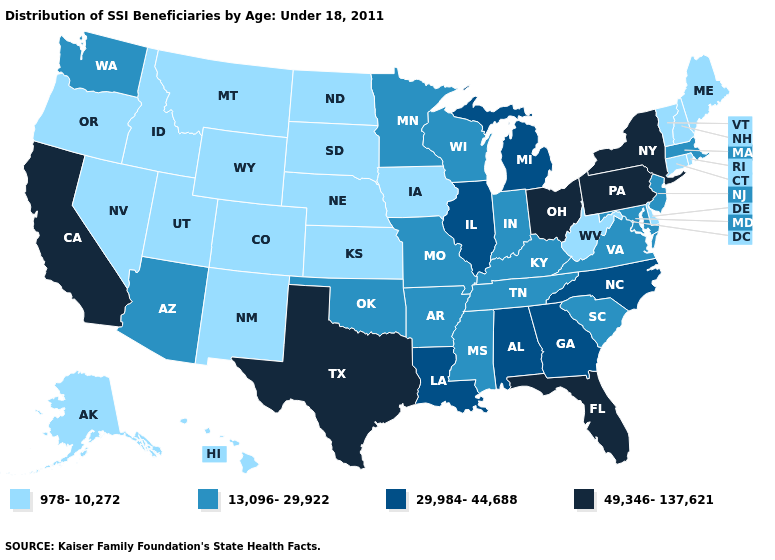Name the states that have a value in the range 13,096-29,922?
Short answer required. Arizona, Arkansas, Indiana, Kentucky, Maryland, Massachusetts, Minnesota, Mississippi, Missouri, New Jersey, Oklahoma, South Carolina, Tennessee, Virginia, Washington, Wisconsin. What is the value of Delaware?
Short answer required. 978-10,272. What is the lowest value in the South?
Answer briefly. 978-10,272. What is the value of Maine?
Quick response, please. 978-10,272. What is the value of Arkansas?
Concise answer only. 13,096-29,922. What is the value of Tennessee?
Keep it brief. 13,096-29,922. Does Wyoming have the lowest value in the West?
Short answer required. Yes. Does Kentucky have the same value as Mississippi?
Write a very short answer. Yes. Does Minnesota have a lower value than Pennsylvania?
Concise answer only. Yes. Name the states that have a value in the range 978-10,272?
Concise answer only. Alaska, Colorado, Connecticut, Delaware, Hawaii, Idaho, Iowa, Kansas, Maine, Montana, Nebraska, Nevada, New Hampshire, New Mexico, North Dakota, Oregon, Rhode Island, South Dakota, Utah, Vermont, West Virginia, Wyoming. Which states have the highest value in the USA?
Keep it brief. California, Florida, New York, Ohio, Pennsylvania, Texas. What is the value of Alaska?
Give a very brief answer. 978-10,272. What is the value of Connecticut?
Keep it brief. 978-10,272. What is the lowest value in the USA?
Quick response, please. 978-10,272. Among the states that border Nevada , which have the highest value?
Concise answer only. California. 